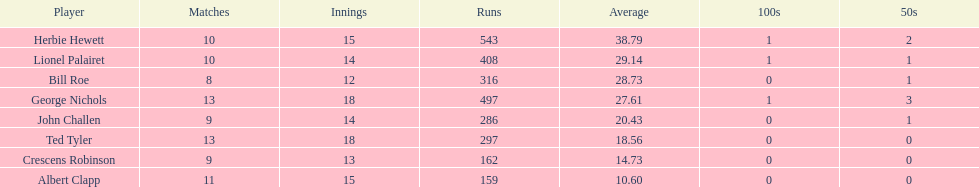How many players played more than 10 matches? 3. 